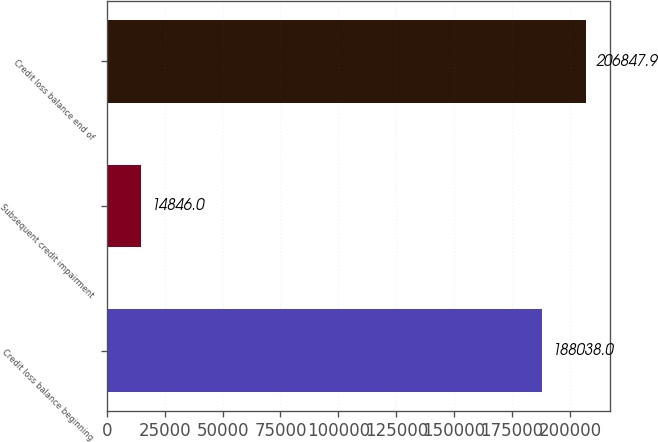Convert chart. <chart><loc_0><loc_0><loc_500><loc_500><bar_chart><fcel>Credit loss balance beginning<fcel>Subsequent credit impairment<fcel>Credit loss balance end of<nl><fcel>188038<fcel>14846<fcel>206848<nl></chart> 